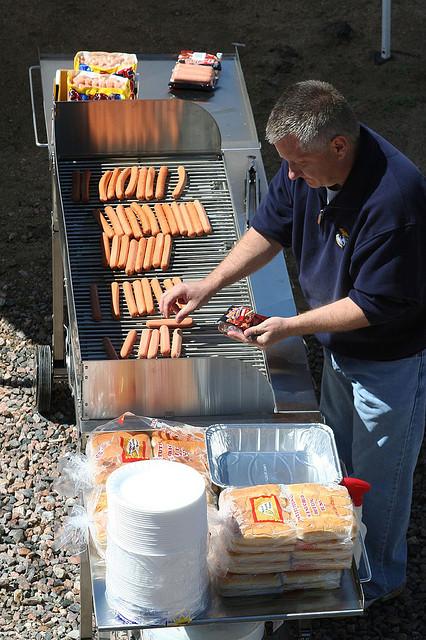What is he cooking?
Answer briefly. Hot dogs. Where are the buns?
Quick response, please. By plates. Why is the man cooking so many hot dogs?
Write a very short answer. Party. 